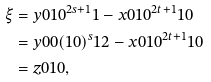<formula> <loc_0><loc_0><loc_500><loc_500>\xi & = y 0 1 0 ^ { 2 s + 1 } 1 - x 0 1 0 ^ { 2 t + 1 } 1 0 \\ & = y 0 0 ( 1 0 ) ^ { s } 1 2 - x 0 1 0 ^ { 2 t + 1 } 1 0 \\ & = z 0 1 0 ,</formula> 